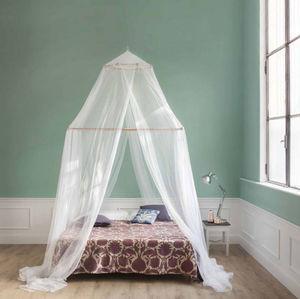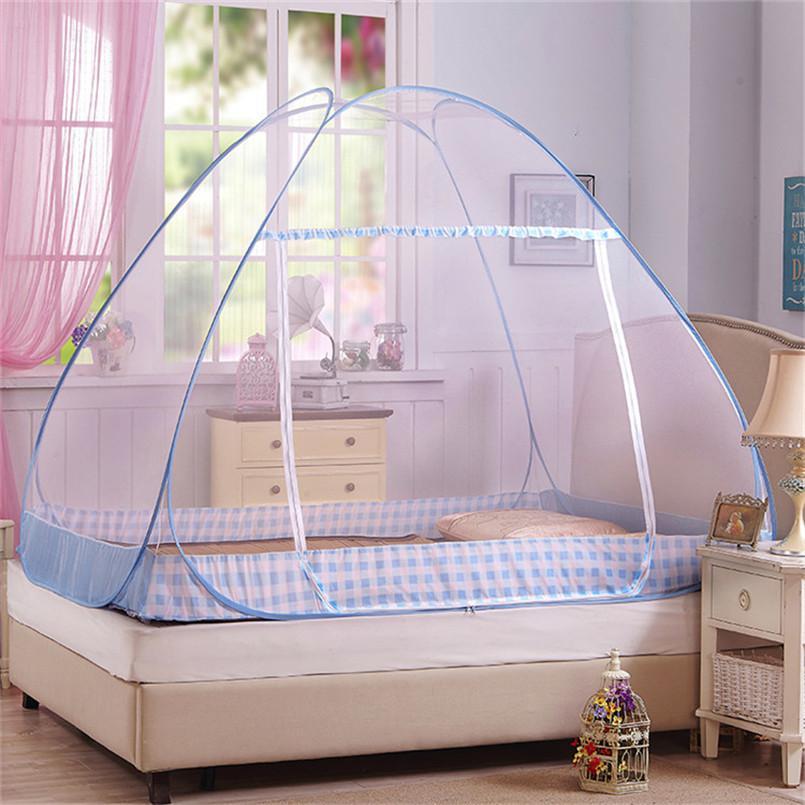The first image is the image on the left, the second image is the image on the right. For the images shown, is this caption "There is a round canopy bed in the right image." true? Answer yes or no. No. The first image is the image on the left, the second image is the image on the right. Considering the images on both sides, is "There are two canopies, one tent and one hanging from the ceiling." valid? Answer yes or no. Yes. 